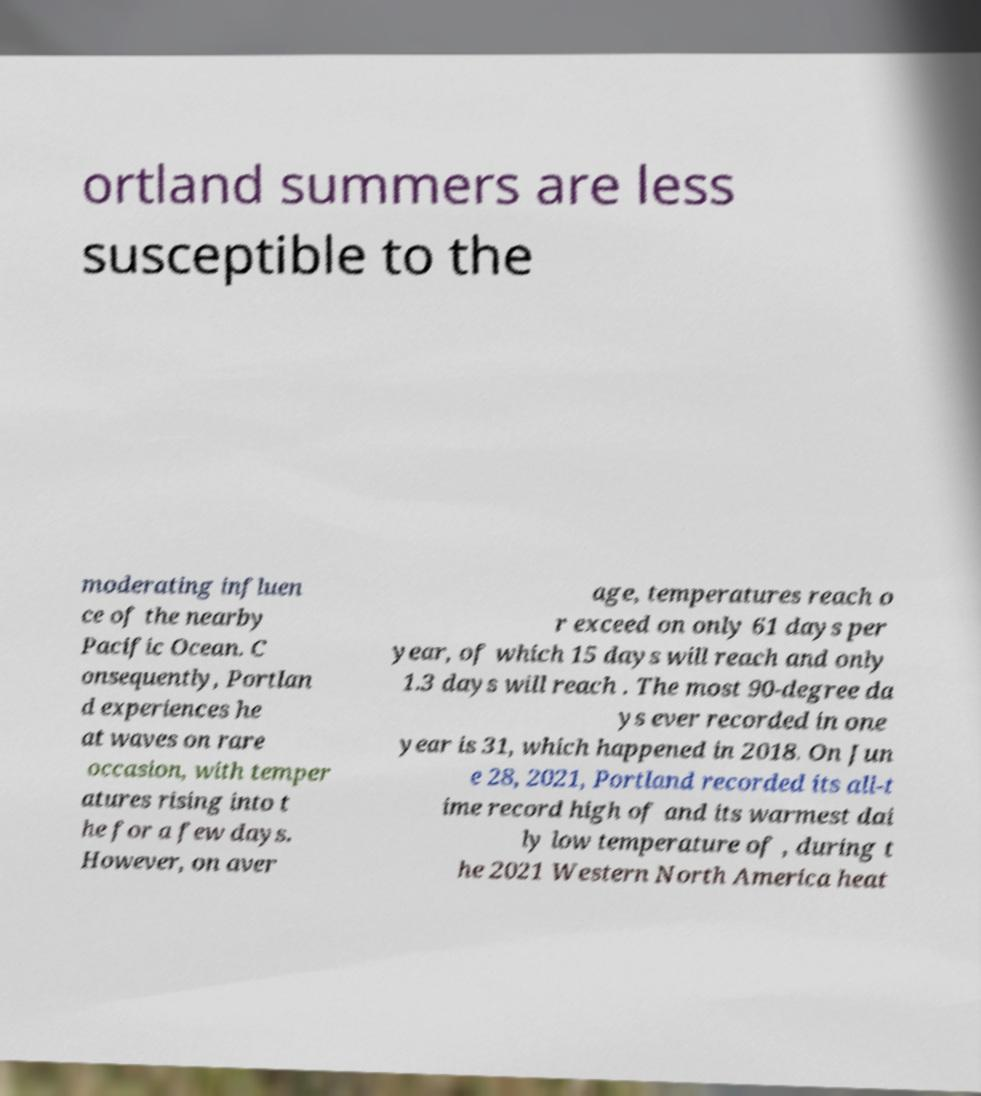Please identify and transcribe the text found in this image. ortland summers are less susceptible to the moderating influen ce of the nearby Pacific Ocean. C onsequently, Portlan d experiences he at waves on rare occasion, with temper atures rising into t he for a few days. However, on aver age, temperatures reach o r exceed on only 61 days per year, of which 15 days will reach and only 1.3 days will reach . The most 90-degree da ys ever recorded in one year is 31, which happened in 2018. On Jun e 28, 2021, Portland recorded its all-t ime record high of and its warmest dai ly low temperature of , during t he 2021 Western North America heat 